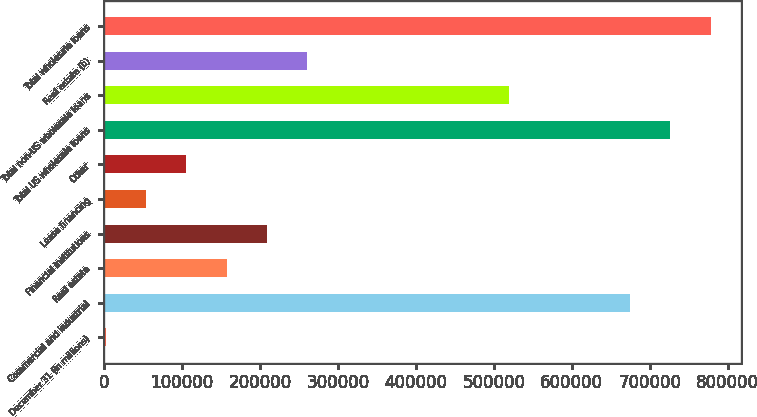Convert chart. <chart><loc_0><loc_0><loc_500><loc_500><bar_chart><fcel>December 31 (in millions)<fcel>Commercial and industrial<fcel>Real estate<fcel>Financial institutions<fcel>Lease financing<fcel>Other<fcel>Total US wholesale loans<fcel>Total non-US wholesale loans<fcel>Real estate (b)<fcel>Total wholesale loans<nl><fcel>2007<fcel>674584<fcel>157217<fcel>208954<fcel>53743.7<fcel>105480<fcel>726321<fcel>519374<fcel>260690<fcel>778058<nl></chart> 